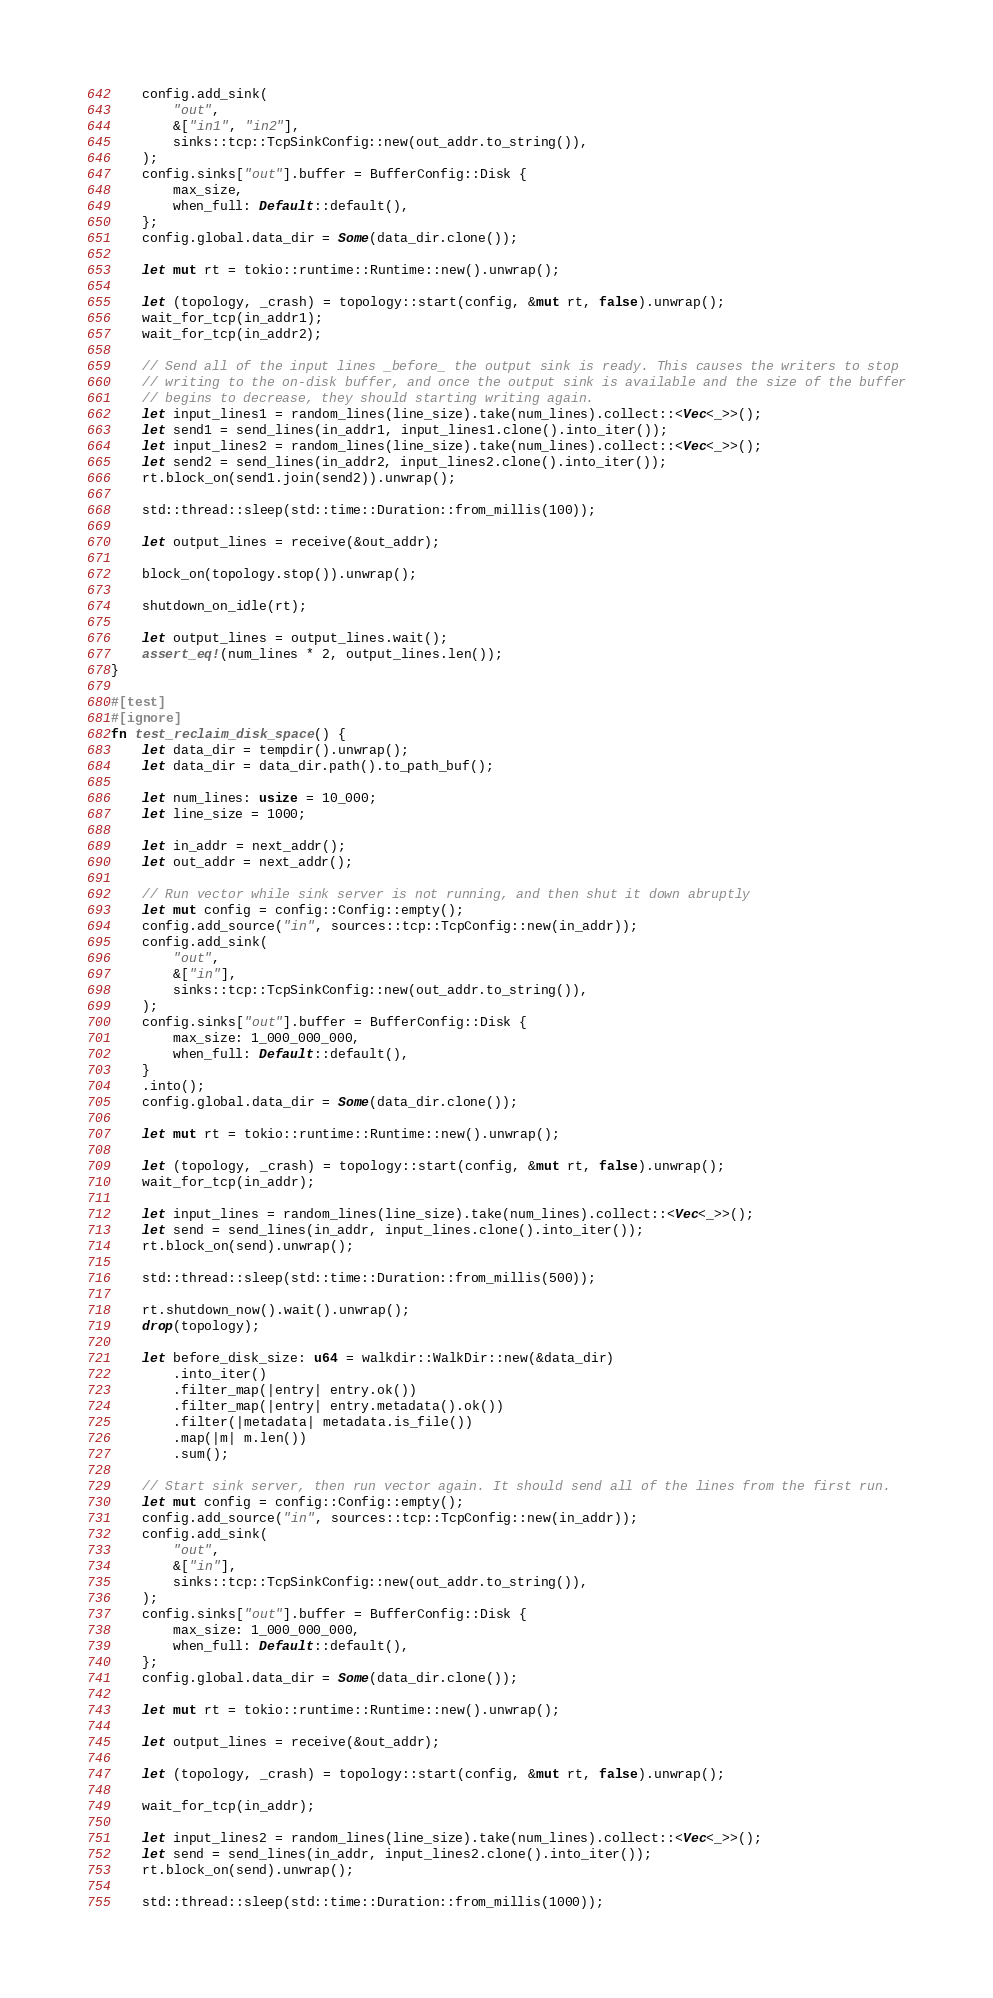Convert code to text. <code><loc_0><loc_0><loc_500><loc_500><_Rust_>    config.add_sink(
        "out",
        &["in1", "in2"],
        sinks::tcp::TcpSinkConfig::new(out_addr.to_string()),
    );
    config.sinks["out"].buffer = BufferConfig::Disk {
        max_size,
        when_full: Default::default(),
    };
    config.global.data_dir = Some(data_dir.clone());

    let mut rt = tokio::runtime::Runtime::new().unwrap();

    let (topology, _crash) = topology::start(config, &mut rt, false).unwrap();
    wait_for_tcp(in_addr1);
    wait_for_tcp(in_addr2);

    // Send all of the input lines _before_ the output sink is ready. This causes the writers to stop
    // writing to the on-disk buffer, and once the output sink is available and the size of the buffer
    // begins to decrease, they should starting writing again.
    let input_lines1 = random_lines(line_size).take(num_lines).collect::<Vec<_>>();
    let send1 = send_lines(in_addr1, input_lines1.clone().into_iter());
    let input_lines2 = random_lines(line_size).take(num_lines).collect::<Vec<_>>();
    let send2 = send_lines(in_addr2, input_lines2.clone().into_iter());
    rt.block_on(send1.join(send2)).unwrap();

    std::thread::sleep(std::time::Duration::from_millis(100));

    let output_lines = receive(&out_addr);

    block_on(topology.stop()).unwrap();

    shutdown_on_idle(rt);

    let output_lines = output_lines.wait();
    assert_eq!(num_lines * 2, output_lines.len());
}

#[test]
#[ignore]
fn test_reclaim_disk_space() {
    let data_dir = tempdir().unwrap();
    let data_dir = data_dir.path().to_path_buf();

    let num_lines: usize = 10_000;
    let line_size = 1000;

    let in_addr = next_addr();
    let out_addr = next_addr();

    // Run vector while sink server is not running, and then shut it down abruptly
    let mut config = config::Config::empty();
    config.add_source("in", sources::tcp::TcpConfig::new(in_addr));
    config.add_sink(
        "out",
        &["in"],
        sinks::tcp::TcpSinkConfig::new(out_addr.to_string()),
    );
    config.sinks["out"].buffer = BufferConfig::Disk {
        max_size: 1_000_000_000,
        when_full: Default::default(),
    }
    .into();
    config.global.data_dir = Some(data_dir.clone());

    let mut rt = tokio::runtime::Runtime::new().unwrap();

    let (topology, _crash) = topology::start(config, &mut rt, false).unwrap();
    wait_for_tcp(in_addr);

    let input_lines = random_lines(line_size).take(num_lines).collect::<Vec<_>>();
    let send = send_lines(in_addr, input_lines.clone().into_iter());
    rt.block_on(send).unwrap();

    std::thread::sleep(std::time::Duration::from_millis(500));

    rt.shutdown_now().wait().unwrap();
    drop(topology);

    let before_disk_size: u64 = walkdir::WalkDir::new(&data_dir)
        .into_iter()
        .filter_map(|entry| entry.ok())
        .filter_map(|entry| entry.metadata().ok())
        .filter(|metadata| metadata.is_file())
        .map(|m| m.len())
        .sum();

    // Start sink server, then run vector again. It should send all of the lines from the first run.
    let mut config = config::Config::empty();
    config.add_source("in", sources::tcp::TcpConfig::new(in_addr));
    config.add_sink(
        "out",
        &["in"],
        sinks::tcp::TcpSinkConfig::new(out_addr.to_string()),
    );
    config.sinks["out"].buffer = BufferConfig::Disk {
        max_size: 1_000_000_000,
        when_full: Default::default(),
    };
    config.global.data_dir = Some(data_dir.clone());

    let mut rt = tokio::runtime::Runtime::new().unwrap();

    let output_lines = receive(&out_addr);

    let (topology, _crash) = topology::start(config, &mut rt, false).unwrap();

    wait_for_tcp(in_addr);

    let input_lines2 = random_lines(line_size).take(num_lines).collect::<Vec<_>>();
    let send = send_lines(in_addr, input_lines2.clone().into_iter());
    rt.block_on(send).unwrap();

    std::thread::sleep(std::time::Duration::from_millis(1000));
</code> 